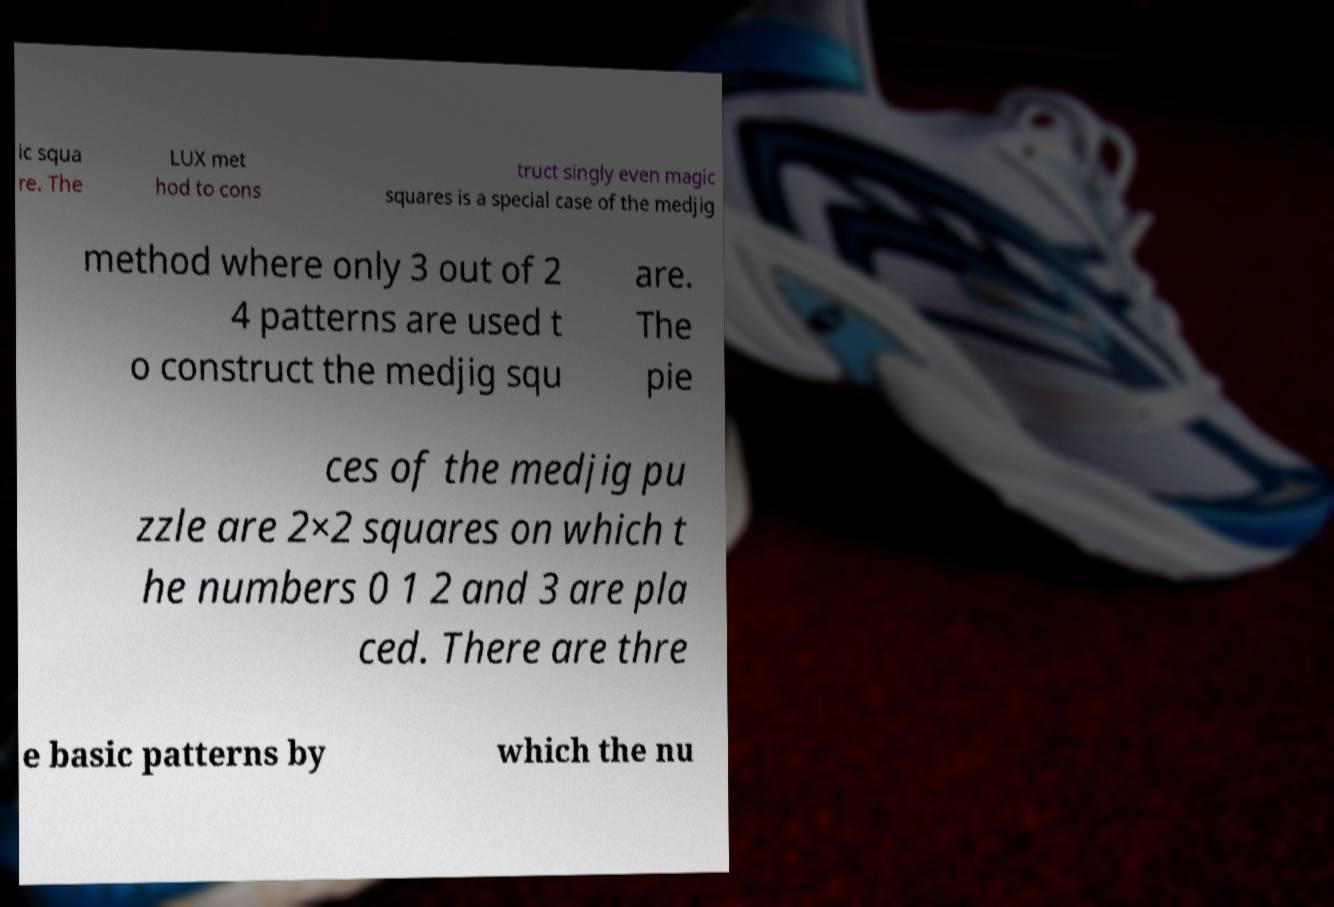Can you accurately transcribe the text from the provided image for me? ic squa re. The LUX met hod to cons truct singly even magic squares is a special case of the medjig method where only 3 out of 2 4 patterns are used t o construct the medjig squ are. The pie ces of the medjig pu zzle are 2×2 squares on which t he numbers 0 1 2 and 3 are pla ced. There are thre e basic patterns by which the nu 